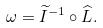<formula> <loc_0><loc_0><loc_500><loc_500>\omega = \widetilde { I } ^ { - 1 } \circ \widehat { L } .</formula> 